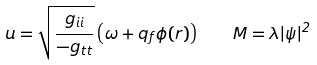Convert formula to latex. <formula><loc_0><loc_0><loc_500><loc_500>u = \sqrt { \frac { g _ { i i } } { - g _ { t t } } } \left ( \omega + q _ { f } \phi ( r ) \right ) \quad M = \lambda | \psi | ^ { 2 }</formula> 